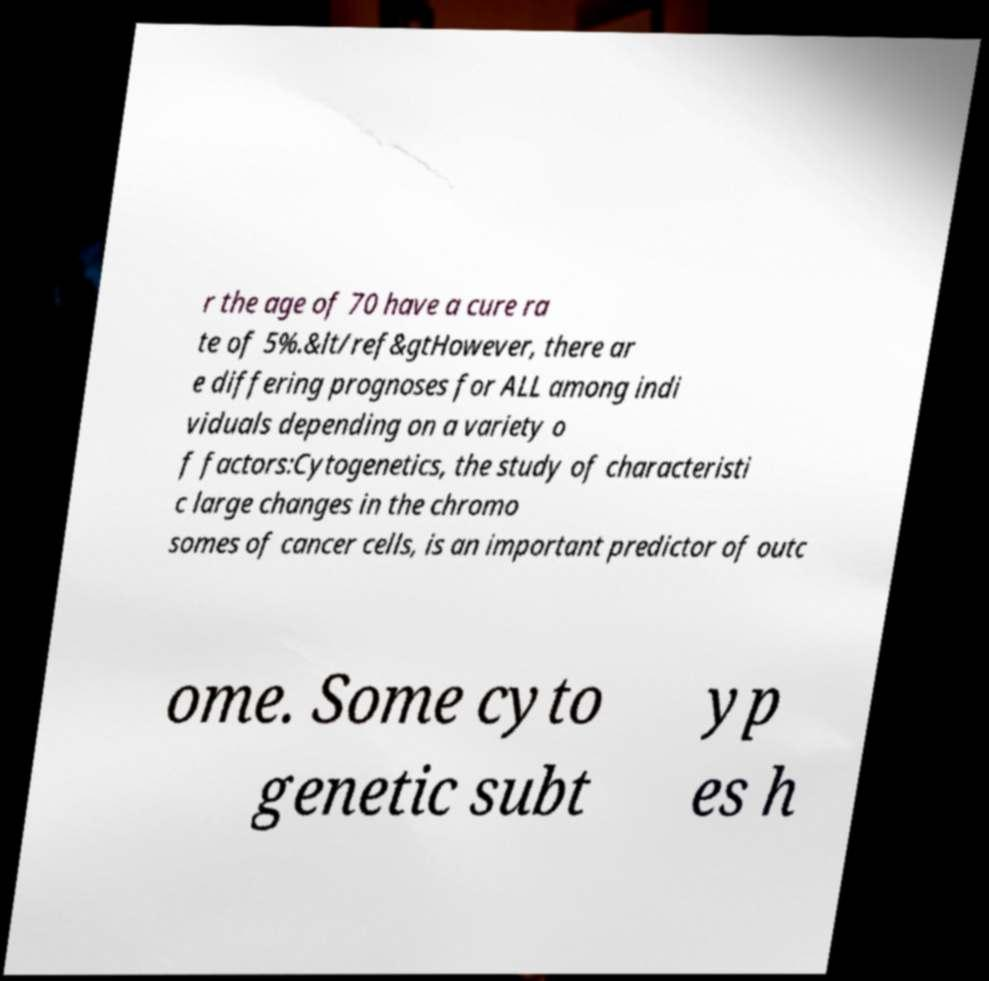Could you extract and type out the text from this image? r the age of 70 have a cure ra te of 5%.&lt/ref&gtHowever, there ar e differing prognoses for ALL among indi viduals depending on a variety o f factors:Cytogenetics, the study of characteristi c large changes in the chromo somes of cancer cells, is an important predictor of outc ome. Some cyto genetic subt yp es h 